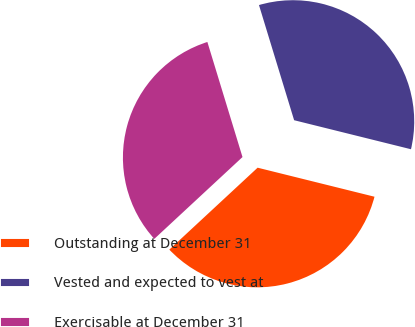Convert chart. <chart><loc_0><loc_0><loc_500><loc_500><pie_chart><fcel>Outstanding at December 31<fcel>Vested and expected to vest at<fcel>Exercisable at December 31<nl><fcel>34.22%<fcel>33.59%<fcel>32.19%<nl></chart> 